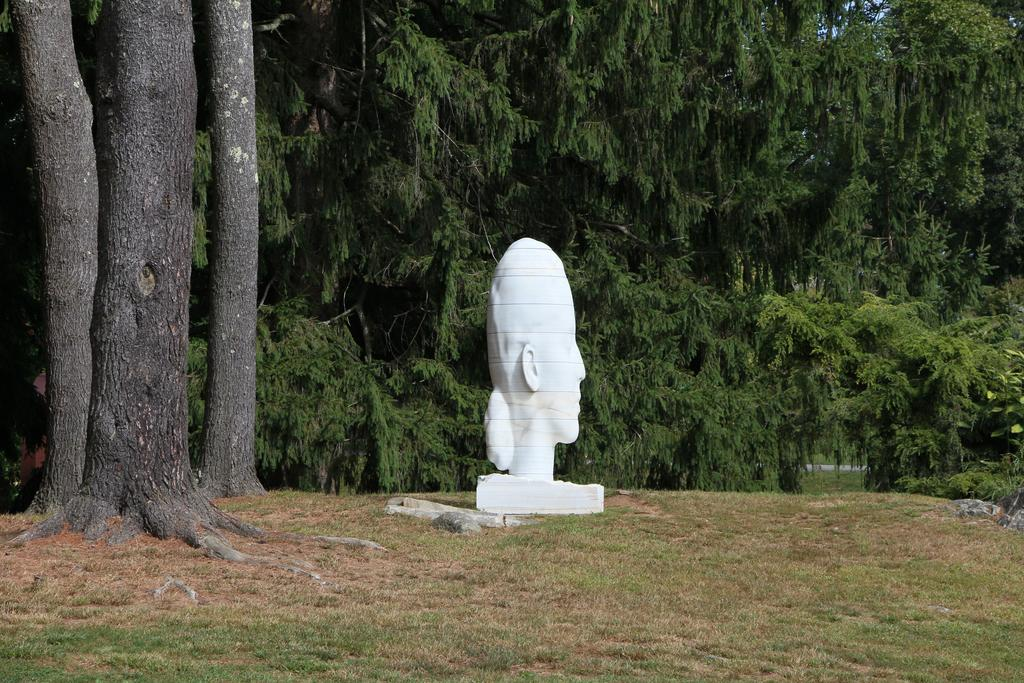What is the main subject of the image? There is a sculpture in the image. Where is the sculpture located? The sculpture is placed in a grass field. What can be seen in the background of the image? There is a group of trees in the background of the image. What type of adjustment is being made to the train in the image? There is no train present in the image; it only features a sculpture in a grass field with a group of trees in the background. 